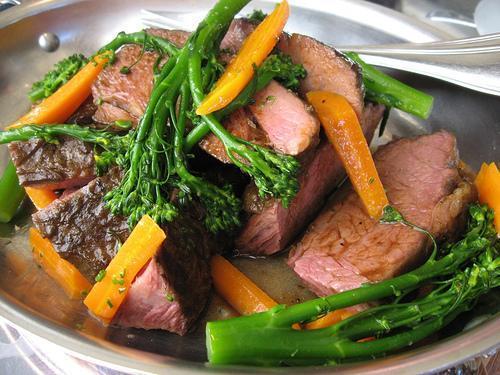How many carrots are in the picture?
Give a very brief answer. 5. 